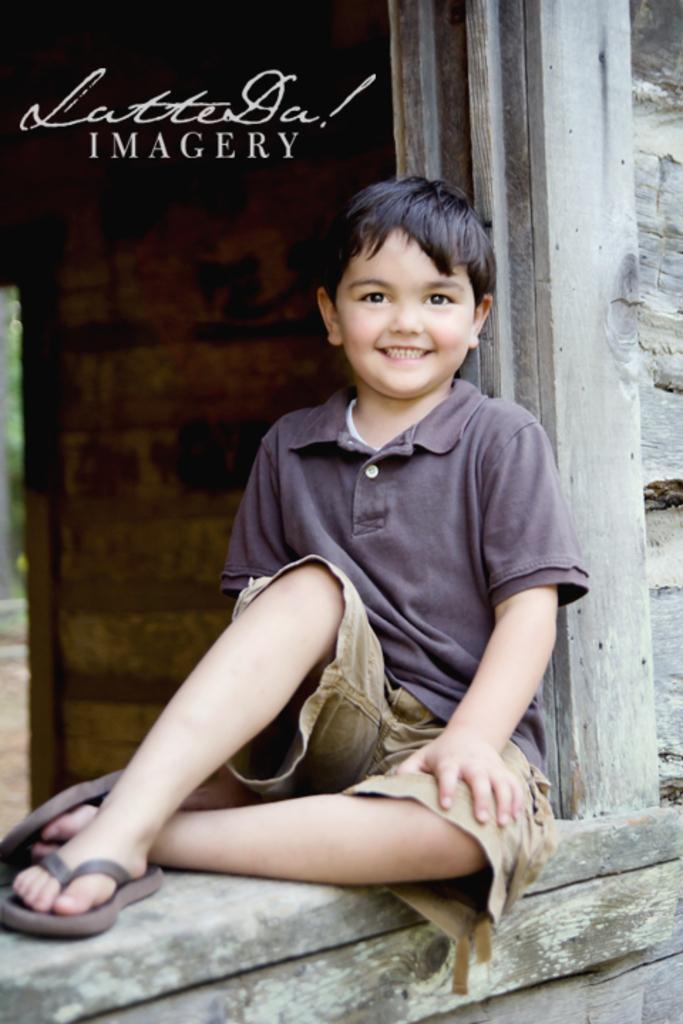Can you describe this image briefly? There is a boy sitting on a wooden surface. In the back there is a wall. In the left top corner something is written on the image. 